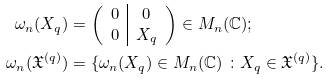<formula> <loc_0><loc_0><loc_500><loc_500>\omega _ { n } ( X _ { q } ) & = \left ( \begin{array} { c | c c } 0 & 0 \\ 0 & X _ { q } \end{array} \right ) \in M _ { n } ( { \mathbb { C } } ) ; \\ \omega _ { n } ( \mathfrak X ^ { ( q ) } ) & = \{ \omega _ { n } ( X _ { q } ) \in M _ { n } ( { \mathbb { C } } ) \ \colon X _ { q } \in \mathfrak X ^ { ( q ) } \} .</formula> 